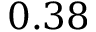<formula> <loc_0><loc_0><loc_500><loc_500>0 . 3 8</formula> 